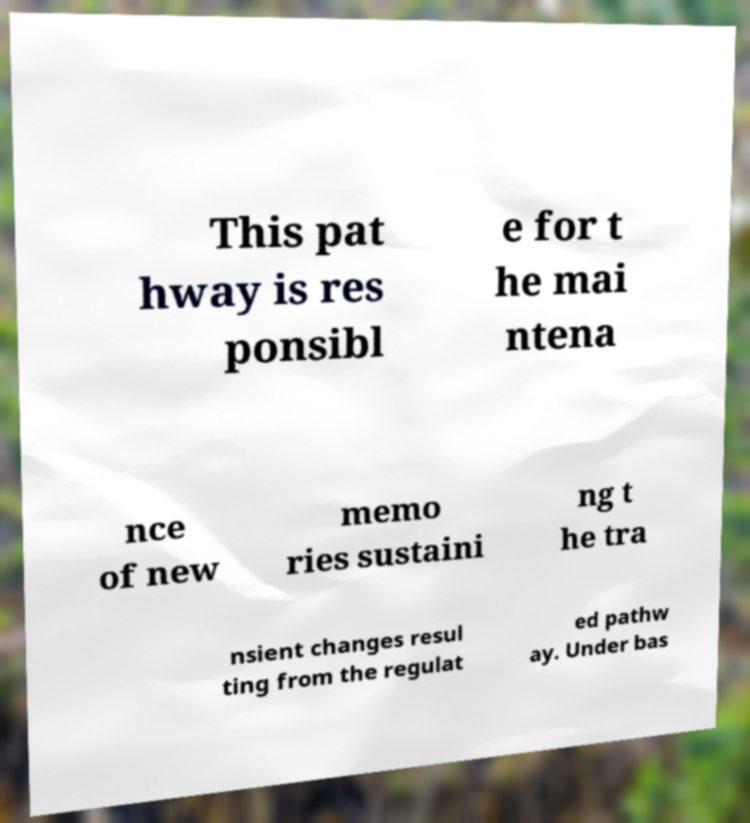Can you accurately transcribe the text from the provided image for me? This pat hway is res ponsibl e for t he mai ntena nce of new memo ries sustaini ng t he tra nsient changes resul ting from the regulat ed pathw ay. Under bas 